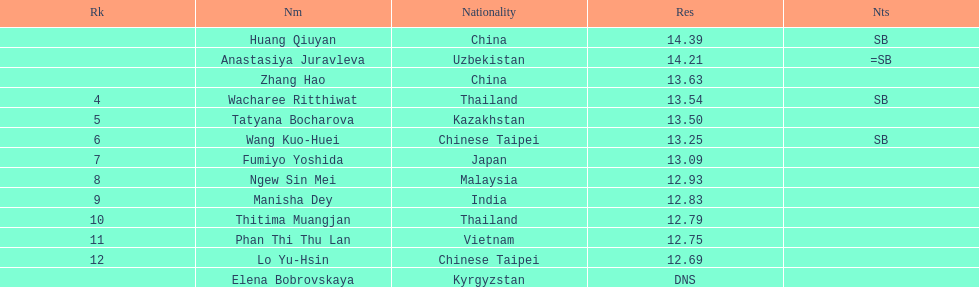Could you parse the entire table as a dict? {'header': ['Rk', 'Nm', 'Nationality', 'Res', 'Nts'], 'rows': [['', 'Huang Qiuyan', 'China', '14.39', 'SB'], ['', 'Anastasiya Juravleva', 'Uzbekistan', '14.21', '=SB'], ['', 'Zhang Hao', 'China', '13.63', ''], ['4', 'Wacharee Ritthiwat', 'Thailand', '13.54', 'SB'], ['5', 'Tatyana Bocharova', 'Kazakhstan', '13.50', ''], ['6', 'Wang Kuo-Huei', 'Chinese Taipei', '13.25', 'SB'], ['7', 'Fumiyo Yoshida', 'Japan', '13.09', ''], ['8', 'Ngew Sin Mei', 'Malaysia', '12.93', ''], ['9', 'Manisha Dey', 'India', '12.83', ''], ['10', 'Thitima Muangjan', 'Thailand', '12.79', ''], ['11', 'Phan Thi Thu Lan', 'Vietnam', '12.75', ''], ['12', 'Lo Yu-Hsin', 'Chinese Taipei', '12.69', ''], ['', 'Elena Bobrovskaya', 'Kyrgyzstan', 'DNS', '']]} How many contestants were from thailand? 2. 